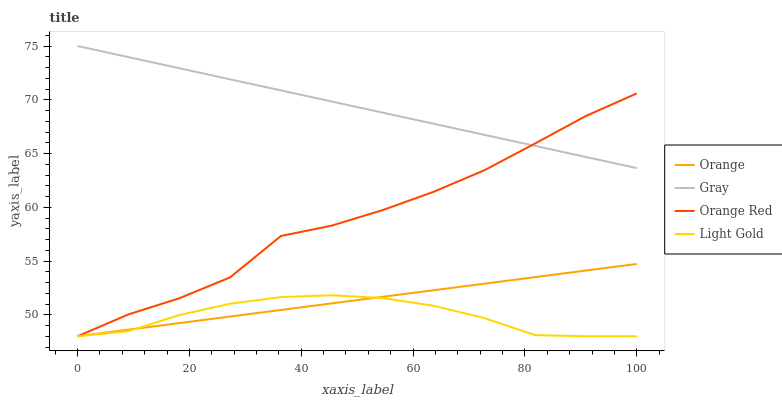Does Light Gold have the minimum area under the curve?
Answer yes or no. Yes. Does Gray have the maximum area under the curve?
Answer yes or no. Yes. Does Gray have the minimum area under the curve?
Answer yes or no. No. Does Light Gold have the maximum area under the curve?
Answer yes or no. No. Is Orange the smoothest?
Answer yes or no. Yes. Is Orange Red the roughest?
Answer yes or no. Yes. Is Gray the smoothest?
Answer yes or no. No. Is Gray the roughest?
Answer yes or no. No. Does Gray have the lowest value?
Answer yes or no. No. Does Gray have the highest value?
Answer yes or no. Yes. Does Light Gold have the highest value?
Answer yes or no. No. Is Orange less than Gray?
Answer yes or no. Yes. Is Gray greater than Orange?
Answer yes or no. Yes. Does Orange intersect Light Gold?
Answer yes or no. Yes. Is Orange less than Light Gold?
Answer yes or no. No. Is Orange greater than Light Gold?
Answer yes or no. No. Does Orange intersect Gray?
Answer yes or no. No. 